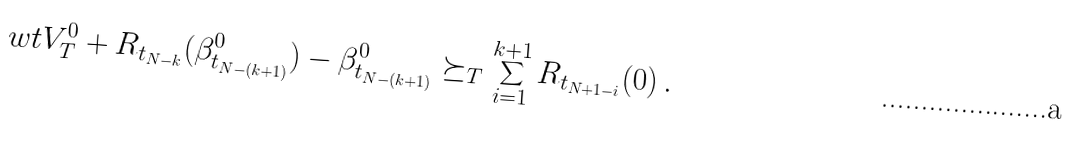Convert formula to latex. <formula><loc_0><loc_0><loc_500><loc_500>\ w t V ^ { 0 } _ { T } + R _ { t _ { N - k } } ( \beta ^ { 0 } _ { t _ { N - ( k + 1 ) } } ) - \beta ^ { 0 } _ { t _ { N - ( k + 1 ) } } \succeq _ { T } \sum _ { i = 1 } ^ { k + 1 } R _ { t _ { N + 1 - i } } ( 0 ) \, .</formula> 